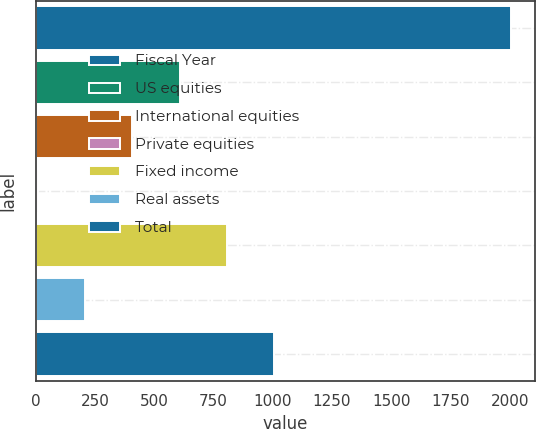<chart> <loc_0><loc_0><loc_500><loc_500><bar_chart><fcel>Fiscal Year<fcel>US equities<fcel>International equities<fcel>Private equities<fcel>Fixed income<fcel>Real assets<fcel>Total<nl><fcel>2006<fcel>606.7<fcel>406.8<fcel>7<fcel>806.6<fcel>206.9<fcel>1006.5<nl></chart> 